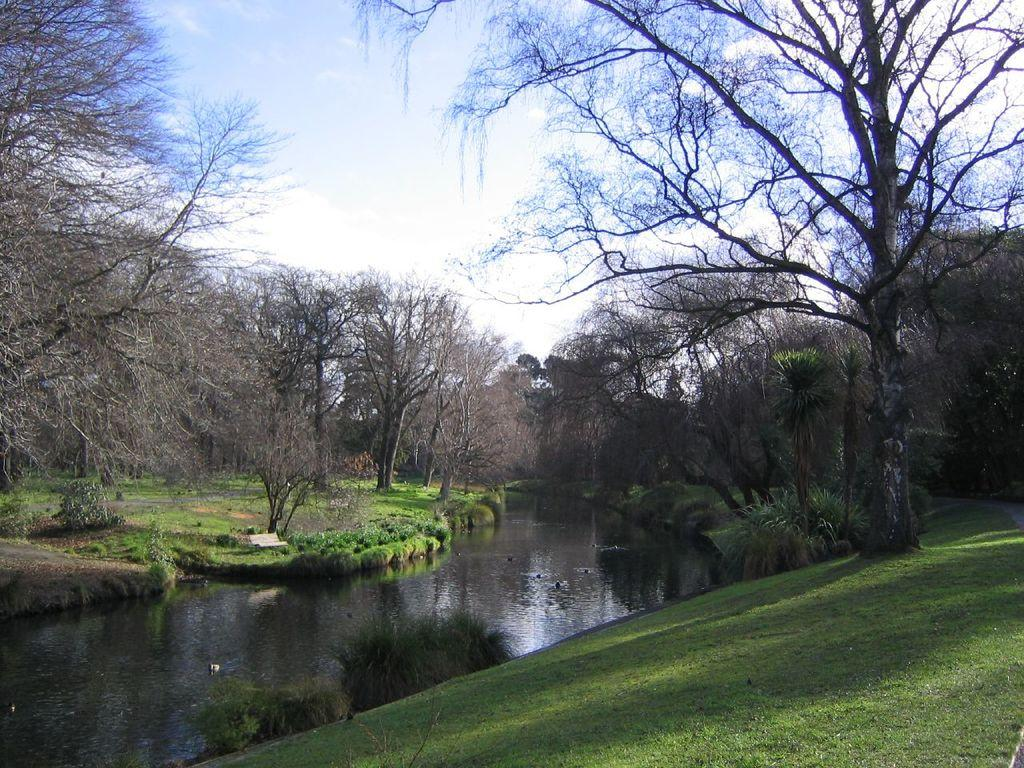What type of vegetation can be seen in the image? There is grass and trees visible in the image. What other features can be observed in the image? There are shadows, water, bushes, and the sky visible in the image. How many trees are present in the image? There are multiple trees in the image. What type of print can be seen on the legs of the person in the image? There is no person present in the image, so there are no legs or prints to observe. 